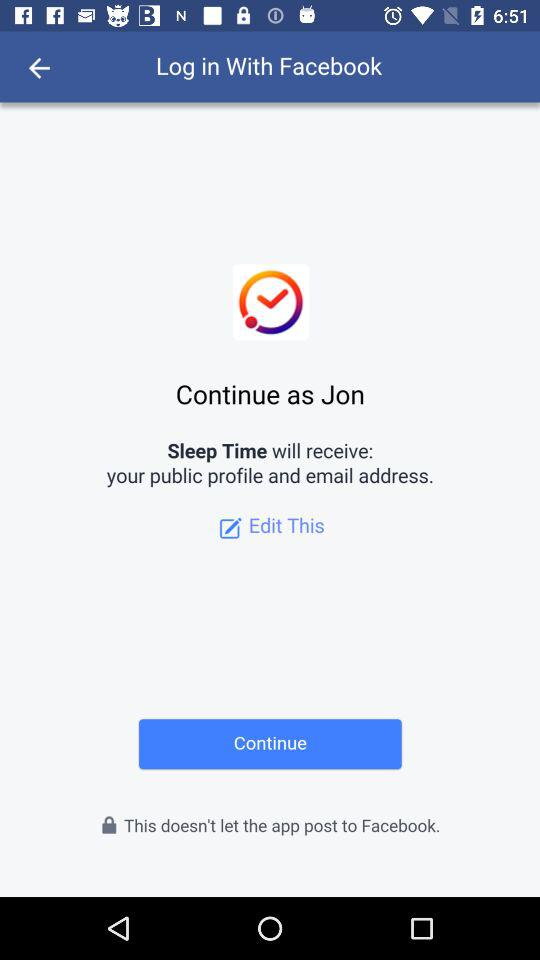What application will receive the public profile and email address? The application is "Sleep Time". 